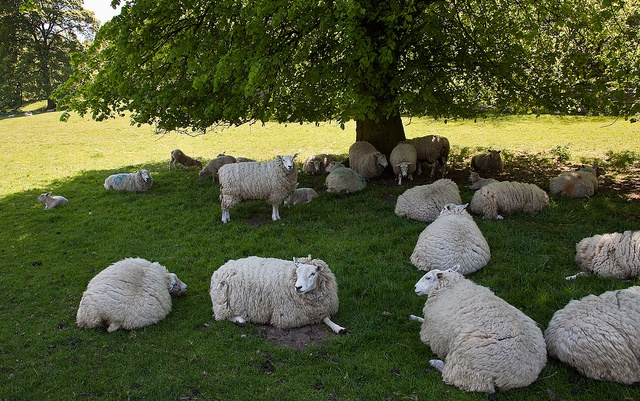Describe the objects in this image and their specific colors. I can see sheep in black, darkgray, and gray tones, sheep in black, darkgreen, gray, and khaki tones, sheep in black, darkgray, and gray tones, sheep in black, darkgray, and gray tones, and sheep in black, darkgray, gray, and darkgreen tones in this image. 